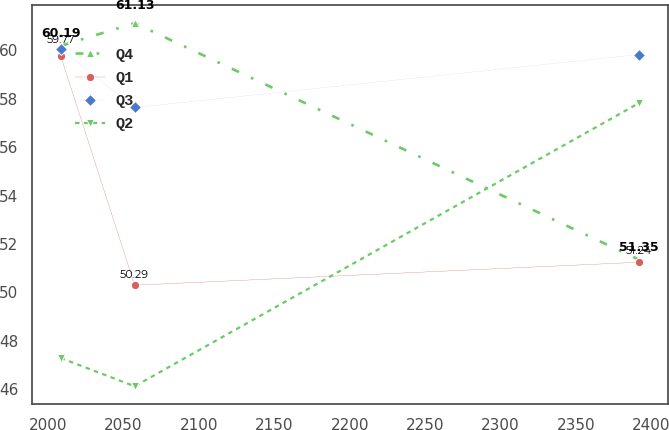Convert chart to OTSL. <chart><loc_0><loc_0><loc_500><loc_500><line_chart><ecel><fcel>Q4<fcel>Q1<fcel>Q3<fcel>Q2<nl><fcel>2008.42<fcel>60.19<fcel>59.77<fcel>60.06<fcel>47.28<nl><fcel>2057.46<fcel>61.13<fcel>50.29<fcel>57.64<fcel>46.11<nl><fcel>2391.75<fcel>51.35<fcel>51.24<fcel>59.83<fcel>57.82<nl></chart> 